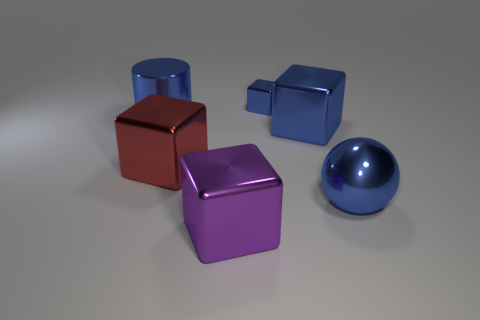Subtract 1 blocks. How many blocks are left? 3 Subtract all purple blocks. How many blocks are left? 3 Subtract all green cubes. Subtract all green cylinders. How many cubes are left? 4 Add 3 tiny purple shiny balls. How many objects exist? 9 Subtract all spheres. How many objects are left? 5 Subtract all large metallic blocks. Subtract all tiny blue metallic blocks. How many objects are left? 2 Add 5 balls. How many balls are left? 6 Add 3 big brown metal cylinders. How many big brown metal cylinders exist? 3 Subtract 0 purple cylinders. How many objects are left? 6 